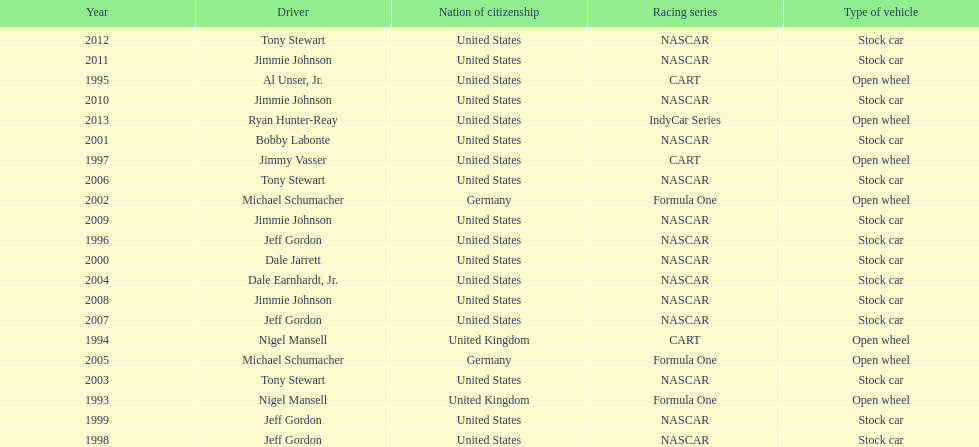Jimmy johnson won how many consecutive espy awards? 4. 